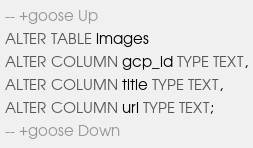<code> <loc_0><loc_0><loc_500><loc_500><_SQL_>-- +goose Up
ALTER TABLE images
ALTER COLUMN gcp_id TYPE TEXT,
ALTER COLUMN title TYPE TEXT,
ALTER COLUMN url TYPE TEXT;
-- +goose Down

</code> 